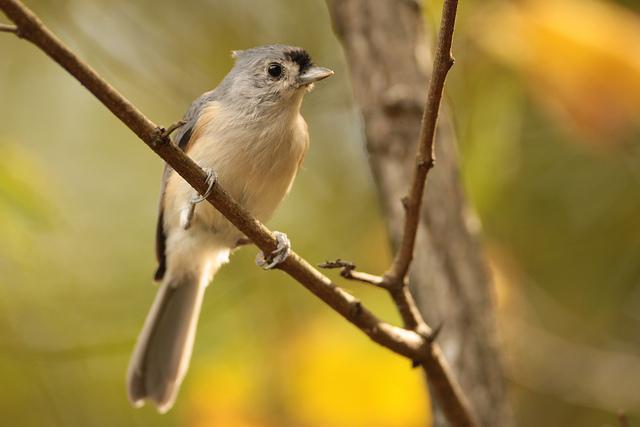How many birds are on the branch?
Give a very brief answer. 1. 